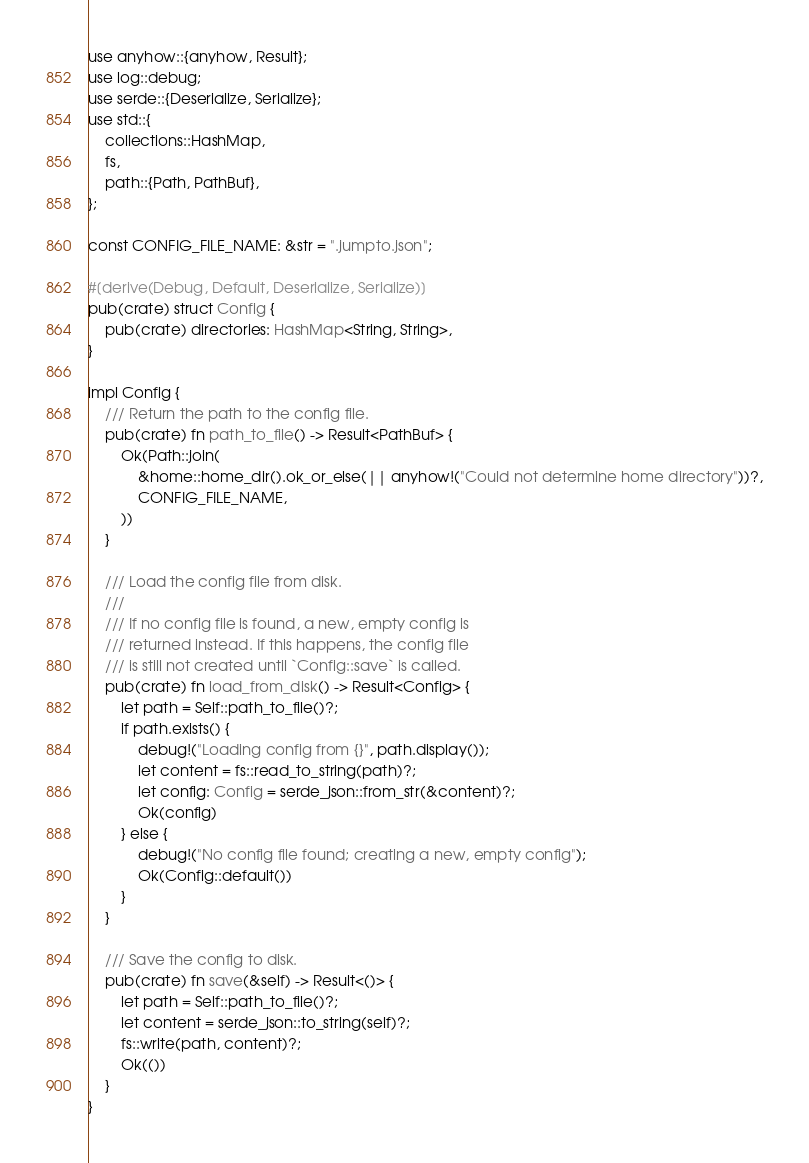Convert code to text. <code><loc_0><loc_0><loc_500><loc_500><_Rust_>use anyhow::{anyhow, Result};
use log::debug;
use serde::{Deserialize, Serialize};
use std::{
    collections::HashMap,
    fs,
    path::{Path, PathBuf},
};

const CONFIG_FILE_NAME: &str = ".jumpto.json";

#[derive(Debug, Default, Deserialize, Serialize)]
pub(crate) struct Config {
    pub(crate) directories: HashMap<String, String>,
}

impl Config {
    /// Return the path to the config file.
    pub(crate) fn path_to_file() -> Result<PathBuf> {
        Ok(Path::join(
            &home::home_dir().ok_or_else(|| anyhow!("Could not determine home directory"))?,
            CONFIG_FILE_NAME,
        ))
    }

    /// Load the config file from disk.
    ///
    /// If no config file is found, a new, empty config is
    /// returned instead. If this happens, the config file
    /// is still not created until `Config::save` is called.
    pub(crate) fn load_from_disk() -> Result<Config> {
        let path = Self::path_to_file()?;
        if path.exists() {
            debug!("Loading config from {}", path.display());
            let content = fs::read_to_string(path)?;
            let config: Config = serde_json::from_str(&content)?;
            Ok(config)
        } else {
            debug!("No config file found; creating a new, empty config");
            Ok(Config::default())
        }
    }

    /// Save the config to disk.
    pub(crate) fn save(&self) -> Result<()> {
        let path = Self::path_to_file()?;
        let content = serde_json::to_string(self)?;
        fs::write(path, content)?;
        Ok(())
    }
}
</code> 